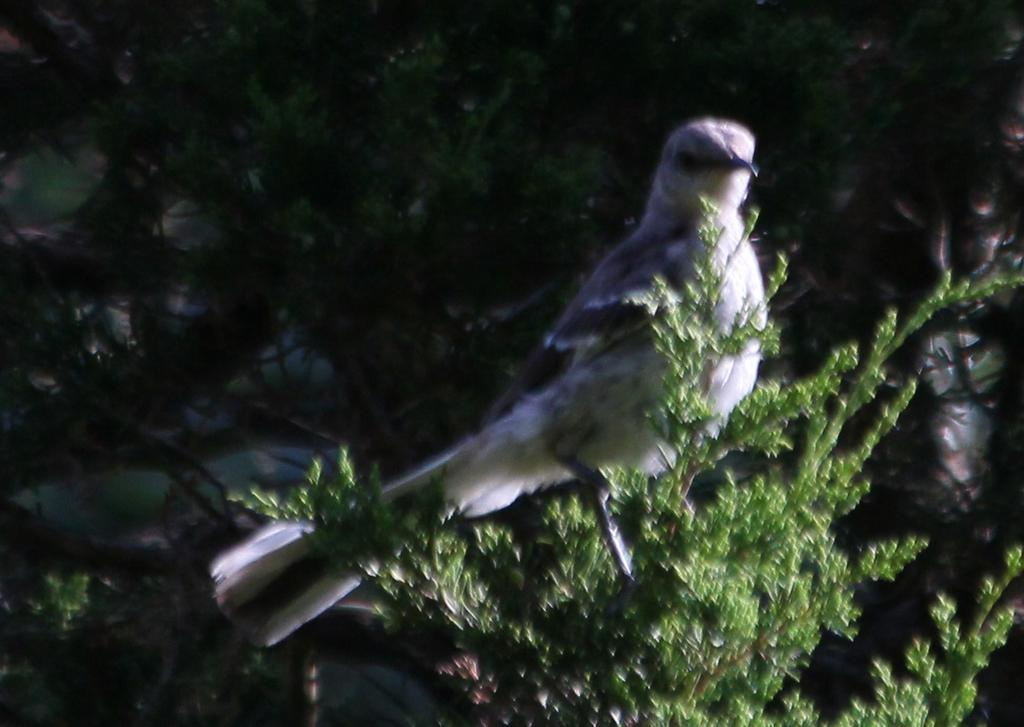What type of animal can be seen in the image? There is a bird in the image. Where is the bird located? The bird is on a tree. What color is the mint in the image? There is no mint present in the image. 